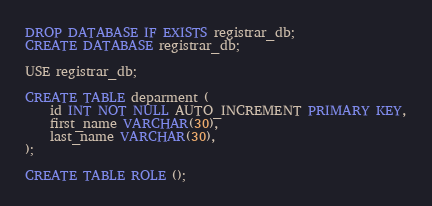<code> <loc_0><loc_0><loc_500><loc_500><_SQL_>DROP DATABASE IF EXISTS registrar_db;
CREATE DATABASE registrar_db;

USE registrar_db;

CREATE TABLE deparment (
    id INT NOT NULL AUTO_INCREMENT PRIMARY KEY,
    first_name VARCHAR(30),
    last_name VARCHAR(30),
);

CREATE TABLE ROLE ();</code> 